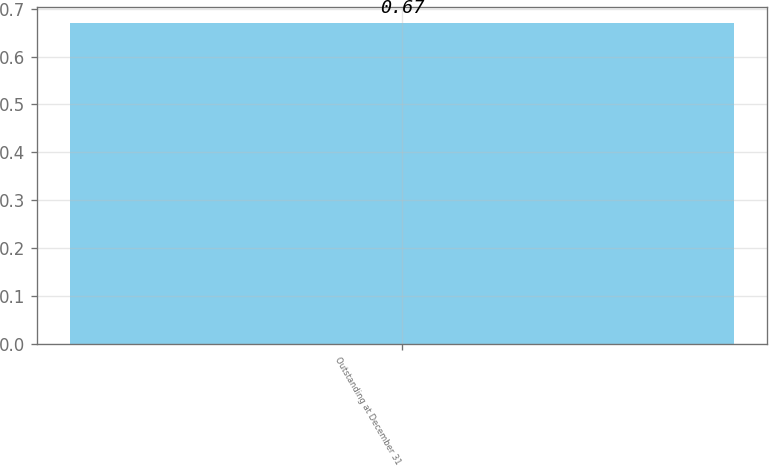<chart> <loc_0><loc_0><loc_500><loc_500><bar_chart><fcel>Outstanding at December 31<nl><fcel>0.67<nl></chart> 